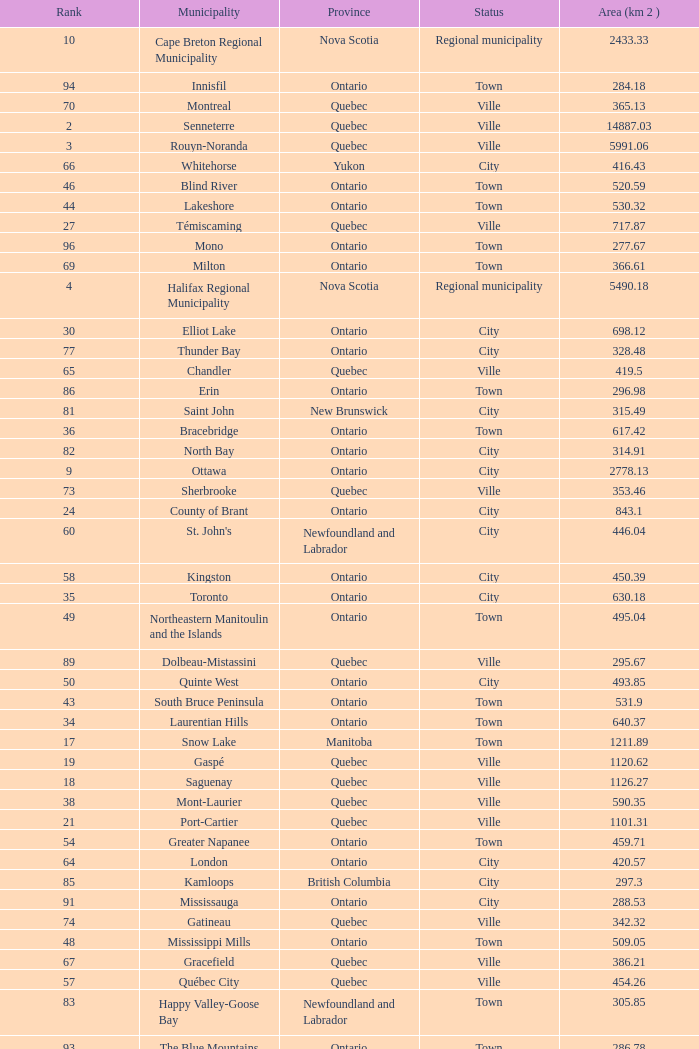What is the highest Area (KM 2) for the Province of Ontario, that has the Status of Town, a Municipality of Minto, and a Rank that's smaller than 84? None. 